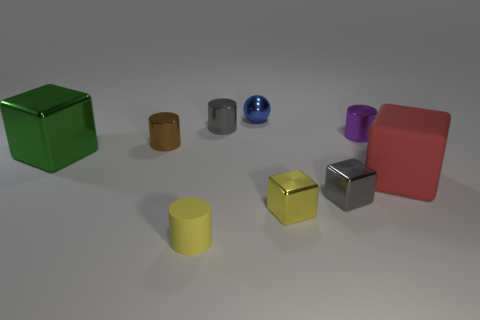There is another thing that is the same color as the small rubber object; what size is it?
Keep it short and to the point. Small. What is the color of the sphere that is made of the same material as the small purple thing?
Offer a terse response. Blue. Do the large matte thing and the tiny shiny cylinder behind the small purple metal cylinder have the same color?
Keep it short and to the point. No. What is the color of the small thing that is behind the tiny purple object and to the right of the gray metal cylinder?
Offer a terse response. Blue. There is a large green block; what number of red matte objects are left of it?
Your response must be concise. 0. What number of things are small blue blocks or tiny cylinders left of the purple metal cylinder?
Provide a succinct answer. 3. Is there a tiny yellow metallic block behind the large object to the left of the tiny gray cylinder?
Your response must be concise. No. The metal cylinder behind the purple shiny cylinder is what color?
Provide a short and direct response. Gray. Are there the same number of big rubber blocks that are to the left of the red matte thing and big red things?
Your answer should be compact. No. There is a small object that is behind the purple metallic cylinder and in front of the blue sphere; what is its shape?
Keep it short and to the point. Cylinder. 